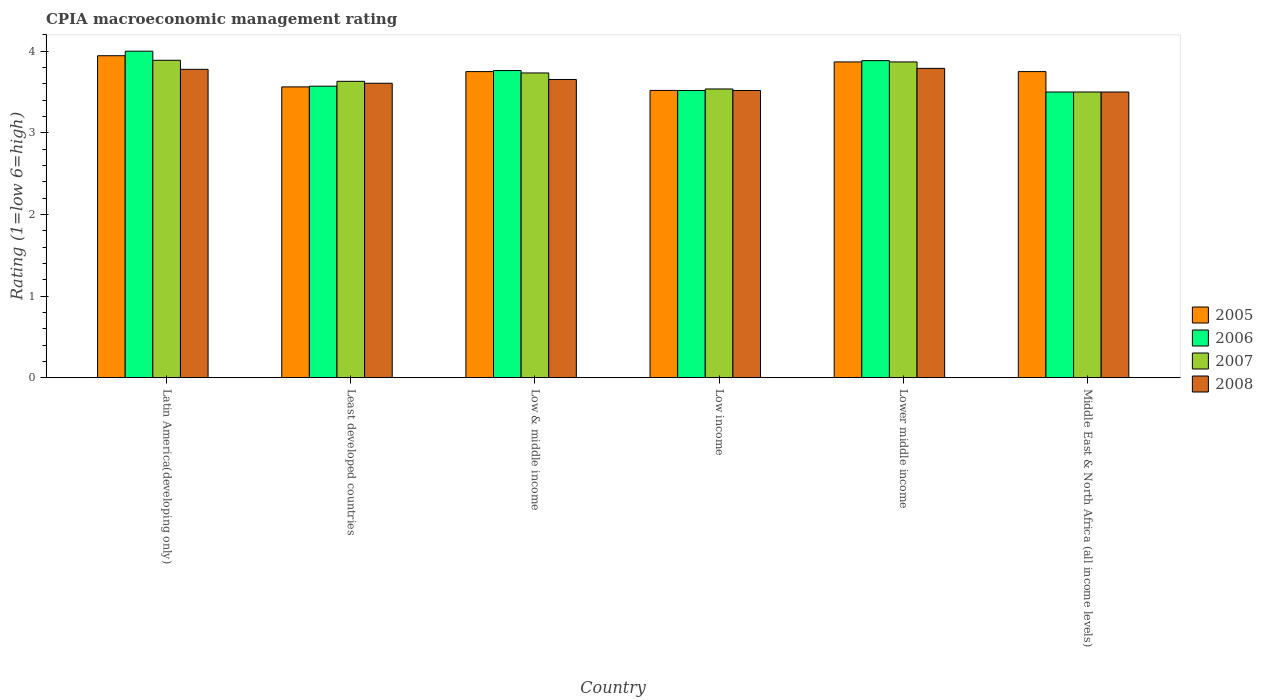How many different coloured bars are there?
Provide a succinct answer. 4. How many groups of bars are there?
Make the answer very short. 6. How many bars are there on the 6th tick from the left?
Provide a short and direct response. 4. What is the label of the 4th group of bars from the left?
Your answer should be compact. Low income. In how many cases, is the number of bars for a given country not equal to the number of legend labels?
Your response must be concise. 0. What is the CPIA rating in 2005 in Latin America(developing only)?
Keep it short and to the point. 3.94. Across all countries, what is the maximum CPIA rating in 2008?
Keep it short and to the point. 3.79. Across all countries, what is the minimum CPIA rating in 2008?
Make the answer very short. 3.5. In which country was the CPIA rating in 2005 maximum?
Your response must be concise. Latin America(developing only). In which country was the CPIA rating in 2007 minimum?
Make the answer very short. Middle East & North Africa (all income levels). What is the total CPIA rating in 2005 in the graph?
Offer a very short reply. 22.39. What is the difference between the CPIA rating in 2005 in Latin America(developing only) and that in Low income?
Make the answer very short. 0.43. What is the difference between the CPIA rating in 2007 in Low income and the CPIA rating in 2005 in Middle East & North Africa (all income levels)?
Make the answer very short. -0.21. What is the average CPIA rating in 2006 per country?
Provide a succinct answer. 3.71. What is the difference between the CPIA rating of/in 2007 and CPIA rating of/in 2006 in Low & middle income?
Your answer should be compact. -0.03. What is the ratio of the CPIA rating in 2007 in Low & middle income to that in Lower middle income?
Offer a terse response. 0.97. What is the difference between the highest and the second highest CPIA rating in 2005?
Your answer should be compact. 0.12. What is the difference between the highest and the lowest CPIA rating in 2008?
Provide a succinct answer. 0.29. In how many countries, is the CPIA rating in 2008 greater than the average CPIA rating in 2008 taken over all countries?
Ensure brevity in your answer.  3. What is the difference between two consecutive major ticks on the Y-axis?
Give a very brief answer. 1. Are the values on the major ticks of Y-axis written in scientific E-notation?
Offer a very short reply. No. What is the title of the graph?
Your response must be concise. CPIA macroeconomic management rating. Does "1995" appear as one of the legend labels in the graph?
Give a very brief answer. No. What is the label or title of the Y-axis?
Your answer should be very brief. Rating (1=low 6=high). What is the Rating (1=low 6=high) in 2005 in Latin America(developing only)?
Your answer should be compact. 3.94. What is the Rating (1=low 6=high) of 2007 in Latin America(developing only)?
Keep it short and to the point. 3.89. What is the Rating (1=low 6=high) in 2008 in Latin America(developing only)?
Offer a very short reply. 3.78. What is the Rating (1=low 6=high) of 2005 in Least developed countries?
Offer a very short reply. 3.56. What is the Rating (1=low 6=high) in 2006 in Least developed countries?
Provide a short and direct response. 3.57. What is the Rating (1=low 6=high) in 2007 in Least developed countries?
Provide a succinct answer. 3.63. What is the Rating (1=low 6=high) of 2008 in Least developed countries?
Provide a short and direct response. 3.61. What is the Rating (1=low 6=high) of 2005 in Low & middle income?
Your answer should be compact. 3.75. What is the Rating (1=low 6=high) of 2006 in Low & middle income?
Give a very brief answer. 3.76. What is the Rating (1=low 6=high) in 2007 in Low & middle income?
Give a very brief answer. 3.73. What is the Rating (1=low 6=high) of 2008 in Low & middle income?
Provide a succinct answer. 3.65. What is the Rating (1=low 6=high) of 2005 in Low income?
Give a very brief answer. 3.52. What is the Rating (1=low 6=high) in 2006 in Low income?
Your response must be concise. 3.52. What is the Rating (1=low 6=high) in 2007 in Low income?
Your response must be concise. 3.54. What is the Rating (1=low 6=high) of 2008 in Low income?
Ensure brevity in your answer.  3.52. What is the Rating (1=low 6=high) in 2005 in Lower middle income?
Offer a very short reply. 3.87. What is the Rating (1=low 6=high) of 2006 in Lower middle income?
Ensure brevity in your answer.  3.88. What is the Rating (1=low 6=high) of 2007 in Lower middle income?
Ensure brevity in your answer.  3.87. What is the Rating (1=low 6=high) in 2008 in Lower middle income?
Make the answer very short. 3.79. What is the Rating (1=low 6=high) of 2005 in Middle East & North Africa (all income levels)?
Make the answer very short. 3.75. What is the Rating (1=low 6=high) in 2007 in Middle East & North Africa (all income levels)?
Provide a succinct answer. 3.5. Across all countries, what is the maximum Rating (1=low 6=high) in 2005?
Your answer should be very brief. 3.94. Across all countries, what is the maximum Rating (1=low 6=high) of 2006?
Your answer should be very brief. 4. Across all countries, what is the maximum Rating (1=low 6=high) of 2007?
Your response must be concise. 3.89. Across all countries, what is the maximum Rating (1=low 6=high) of 2008?
Your answer should be compact. 3.79. Across all countries, what is the minimum Rating (1=low 6=high) of 2005?
Give a very brief answer. 3.52. Across all countries, what is the minimum Rating (1=low 6=high) of 2006?
Keep it short and to the point. 3.5. What is the total Rating (1=low 6=high) in 2005 in the graph?
Offer a very short reply. 22.39. What is the total Rating (1=low 6=high) in 2006 in the graph?
Your answer should be very brief. 22.24. What is the total Rating (1=low 6=high) in 2007 in the graph?
Provide a succinct answer. 22.16. What is the total Rating (1=low 6=high) in 2008 in the graph?
Offer a terse response. 21.85. What is the difference between the Rating (1=low 6=high) of 2005 in Latin America(developing only) and that in Least developed countries?
Give a very brief answer. 0.38. What is the difference between the Rating (1=low 6=high) of 2006 in Latin America(developing only) and that in Least developed countries?
Give a very brief answer. 0.43. What is the difference between the Rating (1=low 6=high) of 2007 in Latin America(developing only) and that in Least developed countries?
Your answer should be very brief. 0.26. What is the difference between the Rating (1=low 6=high) of 2008 in Latin America(developing only) and that in Least developed countries?
Make the answer very short. 0.17. What is the difference between the Rating (1=low 6=high) of 2005 in Latin America(developing only) and that in Low & middle income?
Offer a terse response. 0.19. What is the difference between the Rating (1=low 6=high) in 2006 in Latin America(developing only) and that in Low & middle income?
Provide a succinct answer. 0.24. What is the difference between the Rating (1=low 6=high) in 2007 in Latin America(developing only) and that in Low & middle income?
Make the answer very short. 0.16. What is the difference between the Rating (1=low 6=high) of 2008 in Latin America(developing only) and that in Low & middle income?
Offer a terse response. 0.12. What is the difference between the Rating (1=low 6=high) in 2005 in Latin America(developing only) and that in Low income?
Keep it short and to the point. 0.43. What is the difference between the Rating (1=low 6=high) in 2006 in Latin America(developing only) and that in Low income?
Your answer should be very brief. 0.48. What is the difference between the Rating (1=low 6=high) of 2007 in Latin America(developing only) and that in Low income?
Keep it short and to the point. 0.35. What is the difference between the Rating (1=low 6=high) in 2008 in Latin America(developing only) and that in Low income?
Your answer should be very brief. 0.26. What is the difference between the Rating (1=low 6=high) in 2005 in Latin America(developing only) and that in Lower middle income?
Your answer should be very brief. 0.08. What is the difference between the Rating (1=low 6=high) in 2006 in Latin America(developing only) and that in Lower middle income?
Offer a very short reply. 0.12. What is the difference between the Rating (1=low 6=high) of 2007 in Latin America(developing only) and that in Lower middle income?
Give a very brief answer. 0.02. What is the difference between the Rating (1=low 6=high) in 2008 in Latin America(developing only) and that in Lower middle income?
Your answer should be very brief. -0.01. What is the difference between the Rating (1=low 6=high) in 2005 in Latin America(developing only) and that in Middle East & North Africa (all income levels)?
Your response must be concise. 0.19. What is the difference between the Rating (1=low 6=high) in 2007 in Latin America(developing only) and that in Middle East & North Africa (all income levels)?
Give a very brief answer. 0.39. What is the difference between the Rating (1=low 6=high) of 2008 in Latin America(developing only) and that in Middle East & North Africa (all income levels)?
Your answer should be compact. 0.28. What is the difference between the Rating (1=low 6=high) in 2005 in Least developed countries and that in Low & middle income?
Keep it short and to the point. -0.19. What is the difference between the Rating (1=low 6=high) of 2006 in Least developed countries and that in Low & middle income?
Your answer should be compact. -0.19. What is the difference between the Rating (1=low 6=high) in 2007 in Least developed countries and that in Low & middle income?
Ensure brevity in your answer.  -0.1. What is the difference between the Rating (1=low 6=high) in 2008 in Least developed countries and that in Low & middle income?
Offer a terse response. -0.05. What is the difference between the Rating (1=low 6=high) of 2005 in Least developed countries and that in Low income?
Offer a very short reply. 0.04. What is the difference between the Rating (1=low 6=high) of 2006 in Least developed countries and that in Low income?
Keep it short and to the point. 0.05. What is the difference between the Rating (1=low 6=high) in 2007 in Least developed countries and that in Low income?
Provide a short and direct response. 0.09. What is the difference between the Rating (1=low 6=high) of 2008 in Least developed countries and that in Low income?
Provide a short and direct response. 0.09. What is the difference between the Rating (1=low 6=high) in 2005 in Least developed countries and that in Lower middle income?
Offer a terse response. -0.31. What is the difference between the Rating (1=low 6=high) in 2006 in Least developed countries and that in Lower middle income?
Ensure brevity in your answer.  -0.31. What is the difference between the Rating (1=low 6=high) of 2007 in Least developed countries and that in Lower middle income?
Make the answer very short. -0.24. What is the difference between the Rating (1=low 6=high) in 2008 in Least developed countries and that in Lower middle income?
Your response must be concise. -0.18. What is the difference between the Rating (1=low 6=high) in 2005 in Least developed countries and that in Middle East & North Africa (all income levels)?
Keep it short and to the point. -0.19. What is the difference between the Rating (1=low 6=high) in 2006 in Least developed countries and that in Middle East & North Africa (all income levels)?
Offer a terse response. 0.07. What is the difference between the Rating (1=low 6=high) in 2007 in Least developed countries and that in Middle East & North Africa (all income levels)?
Your answer should be compact. 0.13. What is the difference between the Rating (1=low 6=high) of 2008 in Least developed countries and that in Middle East & North Africa (all income levels)?
Make the answer very short. 0.11. What is the difference between the Rating (1=low 6=high) of 2005 in Low & middle income and that in Low income?
Offer a terse response. 0.23. What is the difference between the Rating (1=low 6=high) of 2006 in Low & middle income and that in Low income?
Your answer should be compact. 0.24. What is the difference between the Rating (1=low 6=high) of 2007 in Low & middle income and that in Low income?
Your response must be concise. 0.2. What is the difference between the Rating (1=low 6=high) of 2008 in Low & middle income and that in Low income?
Provide a succinct answer. 0.13. What is the difference between the Rating (1=low 6=high) in 2005 in Low & middle income and that in Lower middle income?
Make the answer very short. -0.12. What is the difference between the Rating (1=low 6=high) in 2006 in Low & middle income and that in Lower middle income?
Make the answer very short. -0.12. What is the difference between the Rating (1=low 6=high) of 2007 in Low & middle income and that in Lower middle income?
Offer a very short reply. -0.14. What is the difference between the Rating (1=low 6=high) of 2008 in Low & middle income and that in Lower middle income?
Make the answer very short. -0.14. What is the difference between the Rating (1=low 6=high) of 2005 in Low & middle income and that in Middle East & North Africa (all income levels)?
Your answer should be compact. 0. What is the difference between the Rating (1=low 6=high) in 2006 in Low & middle income and that in Middle East & North Africa (all income levels)?
Offer a terse response. 0.26. What is the difference between the Rating (1=low 6=high) in 2007 in Low & middle income and that in Middle East & North Africa (all income levels)?
Make the answer very short. 0.23. What is the difference between the Rating (1=low 6=high) of 2008 in Low & middle income and that in Middle East & North Africa (all income levels)?
Your answer should be very brief. 0.15. What is the difference between the Rating (1=low 6=high) of 2005 in Low income and that in Lower middle income?
Your answer should be very brief. -0.35. What is the difference between the Rating (1=low 6=high) in 2006 in Low income and that in Lower middle income?
Offer a terse response. -0.37. What is the difference between the Rating (1=low 6=high) of 2007 in Low income and that in Lower middle income?
Give a very brief answer. -0.33. What is the difference between the Rating (1=low 6=high) of 2008 in Low income and that in Lower middle income?
Ensure brevity in your answer.  -0.27. What is the difference between the Rating (1=low 6=high) of 2005 in Low income and that in Middle East & North Africa (all income levels)?
Offer a terse response. -0.23. What is the difference between the Rating (1=low 6=high) in 2006 in Low income and that in Middle East & North Africa (all income levels)?
Offer a very short reply. 0.02. What is the difference between the Rating (1=low 6=high) in 2007 in Low income and that in Middle East & North Africa (all income levels)?
Offer a terse response. 0.04. What is the difference between the Rating (1=low 6=high) in 2008 in Low income and that in Middle East & North Africa (all income levels)?
Make the answer very short. 0.02. What is the difference between the Rating (1=low 6=high) in 2005 in Lower middle income and that in Middle East & North Africa (all income levels)?
Keep it short and to the point. 0.12. What is the difference between the Rating (1=low 6=high) in 2006 in Lower middle income and that in Middle East & North Africa (all income levels)?
Give a very brief answer. 0.38. What is the difference between the Rating (1=low 6=high) in 2007 in Lower middle income and that in Middle East & North Africa (all income levels)?
Your answer should be compact. 0.37. What is the difference between the Rating (1=low 6=high) in 2008 in Lower middle income and that in Middle East & North Africa (all income levels)?
Keep it short and to the point. 0.29. What is the difference between the Rating (1=low 6=high) in 2005 in Latin America(developing only) and the Rating (1=low 6=high) in 2006 in Least developed countries?
Keep it short and to the point. 0.37. What is the difference between the Rating (1=low 6=high) of 2005 in Latin America(developing only) and the Rating (1=low 6=high) of 2007 in Least developed countries?
Ensure brevity in your answer.  0.31. What is the difference between the Rating (1=low 6=high) of 2005 in Latin America(developing only) and the Rating (1=low 6=high) of 2008 in Least developed countries?
Your answer should be compact. 0.34. What is the difference between the Rating (1=low 6=high) of 2006 in Latin America(developing only) and the Rating (1=low 6=high) of 2007 in Least developed countries?
Give a very brief answer. 0.37. What is the difference between the Rating (1=low 6=high) in 2006 in Latin America(developing only) and the Rating (1=low 6=high) in 2008 in Least developed countries?
Ensure brevity in your answer.  0.39. What is the difference between the Rating (1=low 6=high) in 2007 in Latin America(developing only) and the Rating (1=low 6=high) in 2008 in Least developed countries?
Provide a succinct answer. 0.28. What is the difference between the Rating (1=low 6=high) of 2005 in Latin America(developing only) and the Rating (1=low 6=high) of 2006 in Low & middle income?
Your answer should be compact. 0.18. What is the difference between the Rating (1=low 6=high) in 2005 in Latin America(developing only) and the Rating (1=low 6=high) in 2007 in Low & middle income?
Your answer should be compact. 0.21. What is the difference between the Rating (1=low 6=high) in 2005 in Latin America(developing only) and the Rating (1=low 6=high) in 2008 in Low & middle income?
Provide a succinct answer. 0.29. What is the difference between the Rating (1=low 6=high) of 2006 in Latin America(developing only) and the Rating (1=low 6=high) of 2007 in Low & middle income?
Offer a terse response. 0.27. What is the difference between the Rating (1=low 6=high) in 2006 in Latin America(developing only) and the Rating (1=low 6=high) in 2008 in Low & middle income?
Offer a terse response. 0.35. What is the difference between the Rating (1=low 6=high) in 2007 in Latin America(developing only) and the Rating (1=low 6=high) in 2008 in Low & middle income?
Ensure brevity in your answer.  0.24. What is the difference between the Rating (1=low 6=high) in 2005 in Latin America(developing only) and the Rating (1=low 6=high) in 2006 in Low income?
Your answer should be very brief. 0.43. What is the difference between the Rating (1=low 6=high) of 2005 in Latin America(developing only) and the Rating (1=low 6=high) of 2007 in Low income?
Your answer should be very brief. 0.41. What is the difference between the Rating (1=low 6=high) of 2005 in Latin America(developing only) and the Rating (1=low 6=high) of 2008 in Low income?
Keep it short and to the point. 0.43. What is the difference between the Rating (1=low 6=high) in 2006 in Latin America(developing only) and the Rating (1=low 6=high) in 2007 in Low income?
Ensure brevity in your answer.  0.46. What is the difference between the Rating (1=low 6=high) in 2006 in Latin America(developing only) and the Rating (1=low 6=high) in 2008 in Low income?
Your answer should be very brief. 0.48. What is the difference between the Rating (1=low 6=high) of 2007 in Latin America(developing only) and the Rating (1=low 6=high) of 2008 in Low income?
Your answer should be compact. 0.37. What is the difference between the Rating (1=low 6=high) of 2005 in Latin America(developing only) and the Rating (1=low 6=high) of 2006 in Lower middle income?
Ensure brevity in your answer.  0.06. What is the difference between the Rating (1=low 6=high) of 2005 in Latin America(developing only) and the Rating (1=low 6=high) of 2007 in Lower middle income?
Ensure brevity in your answer.  0.08. What is the difference between the Rating (1=low 6=high) of 2005 in Latin America(developing only) and the Rating (1=low 6=high) of 2008 in Lower middle income?
Ensure brevity in your answer.  0.15. What is the difference between the Rating (1=low 6=high) in 2006 in Latin America(developing only) and the Rating (1=low 6=high) in 2007 in Lower middle income?
Your answer should be compact. 0.13. What is the difference between the Rating (1=low 6=high) of 2006 in Latin America(developing only) and the Rating (1=low 6=high) of 2008 in Lower middle income?
Provide a succinct answer. 0.21. What is the difference between the Rating (1=low 6=high) in 2007 in Latin America(developing only) and the Rating (1=low 6=high) in 2008 in Lower middle income?
Provide a succinct answer. 0.1. What is the difference between the Rating (1=low 6=high) of 2005 in Latin America(developing only) and the Rating (1=low 6=high) of 2006 in Middle East & North Africa (all income levels)?
Provide a succinct answer. 0.44. What is the difference between the Rating (1=low 6=high) of 2005 in Latin America(developing only) and the Rating (1=low 6=high) of 2007 in Middle East & North Africa (all income levels)?
Your response must be concise. 0.44. What is the difference between the Rating (1=low 6=high) of 2005 in Latin America(developing only) and the Rating (1=low 6=high) of 2008 in Middle East & North Africa (all income levels)?
Ensure brevity in your answer.  0.44. What is the difference between the Rating (1=low 6=high) in 2007 in Latin America(developing only) and the Rating (1=low 6=high) in 2008 in Middle East & North Africa (all income levels)?
Your response must be concise. 0.39. What is the difference between the Rating (1=low 6=high) in 2005 in Least developed countries and the Rating (1=low 6=high) in 2006 in Low & middle income?
Offer a very short reply. -0.2. What is the difference between the Rating (1=low 6=high) of 2005 in Least developed countries and the Rating (1=low 6=high) of 2007 in Low & middle income?
Provide a short and direct response. -0.17. What is the difference between the Rating (1=low 6=high) in 2005 in Least developed countries and the Rating (1=low 6=high) in 2008 in Low & middle income?
Your answer should be very brief. -0.09. What is the difference between the Rating (1=low 6=high) in 2006 in Least developed countries and the Rating (1=low 6=high) in 2007 in Low & middle income?
Ensure brevity in your answer.  -0.16. What is the difference between the Rating (1=low 6=high) in 2006 in Least developed countries and the Rating (1=low 6=high) in 2008 in Low & middle income?
Keep it short and to the point. -0.08. What is the difference between the Rating (1=low 6=high) of 2007 in Least developed countries and the Rating (1=low 6=high) of 2008 in Low & middle income?
Offer a very short reply. -0.02. What is the difference between the Rating (1=low 6=high) in 2005 in Least developed countries and the Rating (1=low 6=high) in 2006 in Low income?
Make the answer very short. 0.04. What is the difference between the Rating (1=low 6=high) in 2005 in Least developed countries and the Rating (1=low 6=high) in 2007 in Low income?
Give a very brief answer. 0.03. What is the difference between the Rating (1=low 6=high) in 2005 in Least developed countries and the Rating (1=low 6=high) in 2008 in Low income?
Provide a succinct answer. 0.04. What is the difference between the Rating (1=low 6=high) in 2006 in Least developed countries and the Rating (1=low 6=high) in 2007 in Low income?
Keep it short and to the point. 0.03. What is the difference between the Rating (1=low 6=high) of 2006 in Least developed countries and the Rating (1=low 6=high) of 2008 in Low income?
Keep it short and to the point. 0.05. What is the difference between the Rating (1=low 6=high) in 2007 in Least developed countries and the Rating (1=low 6=high) in 2008 in Low income?
Keep it short and to the point. 0.11. What is the difference between the Rating (1=low 6=high) of 2005 in Least developed countries and the Rating (1=low 6=high) of 2006 in Lower middle income?
Ensure brevity in your answer.  -0.32. What is the difference between the Rating (1=low 6=high) in 2005 in Least developed countries and the Rating (1=low 6=high) in 2007 in Lower middle income?
Offer a very short reply. -0.31. What is the difference between the Rating (1=low 6=high) in 2005 in Least developed countries and the Rating (1=low 6=high) in 2008 in Lower middle income?
Offer a very short reply. -0.23. What is the difference between the Rating (1=low 6=high) of 2006 in Least developed countries and the Rating (1=low 6=high) of 2007 in Lower middle income?
Provide a succinct answer. -0.3. What is the difference between the Rating (1=low 6=high) of 2006 in Least developed countries and the Rating (1=low 6=high) of 2008 in Lower middle income?
Keep it short and to the point. -0.22. What is the difference between the Rating (1=low 6=high) in 2007 in Least developed countries and the Rating (1=low 6=high) in 2008 in Lower middle income?
Your answer should be compact. -0.16. What is the difference between the Rating (1=low 6=high) of 2005 in Least developed countries and the Rating (1=low 6=high) of 2006 in Middle East & North Africa (all income levels)?
Give a very brief answer. 0.06. What is the difference between the Rating (1=low 6=high) of 2005 in Least developed countries and the Rating (1=low 6=high) of 2007 in Middle East & North Africa (all income levels)?
Your response must be concise. 0.06. What is the difference between the Rating (1=low 6=high) of 2005 in Least developed countries and the Rating (1=low 6=high) of 2008 in Middle East & North Africa (all income levels)?
Your answer should be very brief. 0.06. What is the difference between the Rating (1=low 6=high) of 2006 in Least developed countries and the Rating (1=low 6=high) of 2007 in Middle East & North Africa (all income levels)?
Provide a short and direct response. 0.07. What is the difference between the Rating (1=low 6=high) of 2006 in Least developed countries and the Rating (1=low 6=high) of 2008 in Middle East & North Africa (all income levels)?
Keep it short and to the point. 0.07. What is the difference between the Rating (1=low 6=high) in 2007 in Least developed countries and the Rating (1=low 6=high) in 2008 in Middle East & North Africa (all income levels)?
Keep it short and to the point. 0.13. What is the difference between the Rating (1=low 6=high) of 2005 in Low & middle income and the Rating (1=low 6=high) of 2006 in Low income?
Provide a succinct answer. 0.23. What is the difference between the Rating (1=low 6=high) in 2005 in Low & middle income and the Rating (1=low 6=high) in 2007 in Low income?
Provide a short and direct response. 0.21. What is the difference between the Rating (1=low 6=high) of 2005 in Low & middle income and the Rating (1=low 6=high) of 2008 in Low income?
Offer a very short reply. 0.23. What is the difference between the Rating (1=low 6=high) in 2006 in Low & middle income and the Rating (1=low 6=high) in 2007 in Low income?
Your answer should be compact. 0.23. What is the difference between the Rating (1=low 6=high) in 2006 in Low & middle income and the Rating (1=low 6=high) in 2008 in Low income?
Your answer should be compact. 0.24. What is the difference between the Rating (1=low 6=high) in 2007 in Low & middle income and the Rating (1=low 6=high) in 2008 in Low income?
Ensure brevity in your answer.  0.21. What is the difference between the Rating (1=low 6=high) of 2005 in Low & middle income and the Rating (1=low 6=high) of 2006 in Lower middle income?
Ensure brevity in your answer.  -0.13. What is the difference between the Rating (1=low 6=high) in 2005 in Low & middle income and the Rating (1=low 6=high) in 2007 in Lower middle income?
Your answer should be very brief. -0.12. What is the difference between the Rating (1=low 6=high) in 2005 in Low & middle income and the Rating (1=low 6=high) in 2008 in Lower middle income?
Keep it short and to the point. -0.04. What is the difference between the Rating (1=low 6=high) of 2006 in Low & middle income and the Rating (1=low 6=high) of 2007 in Lower middle income?
Keep it short and to the point. -0.11. What is the difference between the Rating (1=low 6=high) of 2006 in Low & middle income and the Rating (1=low 6=high) of 2008 in Lower middle income?
Keep it short and to the point. -0.03. What is the difference between the Rating (1=low 6=high) of 2007 in Low & middle income and the Rating (1=low 6=high) of 2008 in Lower middle income?
Offer a very short reply. -0.06. What is the difference between the Rating (1=low 6=high) of 2005 in Low & middle income and the Rating (1=low 6=high) of 2006 in Middle East & North Africa (all income levels)?
Keep it short and to the point. 0.25. What is the difference between the Rating (1=low 6=high) in 2005 in Low & middle income and the Rating (1=low 6=high) in 2007 in Middle East & North Africa (all income levels)?
Provide a short and direct response. 0.25. What is the difference between the Rating (1=low 6=high) of 2006 in Low & middle income and the Rating (1=low 6=high) of 2007 in Middle East & North Africa (all income levels)?
Provide a short and direct response. 0.26. What is the difference between the Rating (1=low 6=high) of 2006 in Low & middle income and the Rating (1=low 6=high) of 2008 in Middle East & North Africa (all income levels)?
Give a very brief answer. 0.26. What is the difference between the Rating (1=low 6=high) of 2007 in Low & middle income and the Rating (1=low 6=high) of 2008 in Middle East & North Africa (all income levels)?
Offer a very short reply. 0.23. What is the difference between the Rating (1=low 6=high) of 2005 in Low income and the Rating (1=low 6=high) of 2006 in Lower middle income?
Ensure brevity in your answer.  -0.37. What is the difference between the Rating (1=low 6=high) of 2005 in Low income and the Rating (1=low 6=high) of 2007 in Lower middle income?
Make the answer very short. -0.35. What is the difference between the Rating (1=low 6=high) in 2005 in Low income and the Rating (1=low 6=high) in 2008 in Lower middle income?
Ensure brevity in your answer.  -0.27. What is the difference between the Rating (1=low 6=high) in 2006 in Low income and the Rating (1=low 6=high) in 2007 in Lower middle income?
Offer a very short reply. -0.35. What is the difference between the Rating (1=low 6=high) of 2006 in Low income and the Rating (1=low 6=high) of 2008 in Lower middle income?
Your answer should be very brief. -0.27. What is the difference between the Rating (1=low 6=high) in 2007 in Low income and the Rating (1=low 6=high) in 2008 in Lower middle income?
Your response must be concise. -0.25. What is the difference between the Rating (1=low 6=high) of 2005 in Low income and the Rating (1=low 6=high) of 2006 in Middle East & North Africa (all income levels)?
Offer a terse response. 0.02. What is the difference between the Rating (1=low 6=high) in 2005 in Low income and the Rating (1=low 6=high) in 2007 in Middle East & North Africa (all income levels)?
Provide a short and direct response. 0.02. What is the difference between the Rating (1=low 6=high) of 2005 in Low income and the Rating (1=low 6=high) of 2008 in Middle East & North Africa (all income levels)?
Ensure brevity in your answer.  0.02. What is the difference between the Rating (1=low 6=high) in 2006 in Low income and the Rating (1=low 6=high) in 2007 in Middle East & North Africa (all income levels)?
Provide a succinct answer. 0.02. What is the difference between the Rating (1=low 6=high) of 2006 in Low income and the Rating (1=low 6=high) of 2008 in Middle East & North Africa (all income levels)?
Offer a very short reply. 0.02. What is the difference between the Rating (1=low 6=high) in 2007 in Low income and the Rating (1=low 6=high) in 2008 in Middle East & North Africa (all income levels)?
Your response must be concise. 0.04. What is the difference between the Rating (1=low 6=high) of 2005 in Lower middle income and the Rating (1=low 6=high) of 2006 in Middle East & North Africa (all income levels)?
Ensure brevity in your answer.  0.37. What is the difference between the Rating (1=low 6=high) of 2005 in Lower middle income and the Rating (1=low 6=high) of 2007 in Middle East & North Africa (all income levels)?
Your answer should be very brief. 0.37. What is the difference between the Rating (1=low 6=high) in 2005 in Lower middle income and the Rating (1=low 6=high) in 2008 in Middle East & North Africa (all income levels)?
Your answer should be very brief. 0.37. What is the difference between the Rating (1=low 6=high) of 2006 in Lower middle income and the Rating (1=low 6=high) of 2007 in Middle East & North Africa (all income levels)?
Your answer should be very brief. 0.38. What is the difference between the Rating (1=low 6=high) in 2006 in Lower middle income and the Rating (1=low 6=high) in 2008 in Middle East & North Africa (all income levels)?
Ensure brevity in your answer.  0.38. What is the difference between the Rating (1=low 6=high) in 2007 in Lower middle income and the Rating (1=low 6=high) in 2008 in Middle East & North Africa (all income levels)?
Provide a short and direct response. 0.37. What is the average Rating (1=low 6=high) of 2005 per country?
Make the answer very short. 3.73. What is the average Rating (1=low 6=high) of 2006 per country?
Make the answer very short. 3.71. What is the average Rating (1=low 6=high) in 2007 per country?
Your response must be concise. 3.69. What is the average Rating (1=low 6=high) of 2008 per country?
Your response must be concise. 3.64. What is the difference between the Rating (1=low 6=high) in 2005 and Rating (1=low 6=high) in 2006 in Latin America(developing only)?
Ensure brevity in your answer.  -0.06. What is the difference between the Rating (1=low 6=high) of 2005 and Rating (1=low 6=high) of 2007 in Latin America(developing only)?
Provide a succinct answer. 0.06. What is the difference between the Rating (1=low 6=high) of 2005 and Rating (1=low 6=high) of 2008 in Latin America(developing only)?
Offer a terse response. 0.17. What is the difference between the Rating (1=low 6=high) in 2006 and Rating (1=low 6=high) in 2008 in Latin America(developing only)?
Offer a very short reply. 0.22. What is the difference between the Rating (1=low 6=high) of 2005 and Rating (1=low 6=high) of 2006 in Least developed countries?
Make the answer very short. -0.01. What is the difference between the Rating (1=low 6=high) in 2005 and Rating (1=low 6=high) in 2007 in Least developed countries?
Your answer should be compact. -0.07. What is the difference between the Rating (1=low 6=high) of 2005 and Rating (1=low 6=high) of 2008 in Least developed countries?
Provide a short and direct response. -0.04. What is the difference between the Rating (1=low 6=high) in 2006 and Rating (1=low 6=high) in 2007 in Least developed countries?
Give a very brief answer. -0.06. What is the difference between the Rating (1=low 6=high) in 2006 and Rating (1=low 6=high) in 2008 in Least developed countries?
Your answer should be compact. -0.04. What is the difference between the Rating (1=low 6=high) of 2007 and Rating (1=low 6=high) of 2008 in Least developed countries?
Your answer should be very brief. 0.02. What is the difference between the Rating (1=low 6=high) in 2005 and Rating (1=low 6=high) in 2006 in Low & middle income?
Your answer should be compact. -0.01. What is the difference between the Rating (1=low 6=high) of 2005 and Rating (1=low 6=high) of 2007 in Low & middle income?
Keep it short and to the point. 0.02. What is the difference between the Rating (1=low 6=high) of 2005 and Rating (1=low 6=high) of 2008 in Low & middle income?
Ensure brevity in your answer.  0.1. What is the difference between the Rating (1=low 6=high) of 2006 and Rating (1=low 6=high) of 2007 in Low & middle income?
Offer a very short reply. 0.03. What is the difference between the Rating (1=low 6=high) in 2006 and Rating (1=low 6=high) in 2008 in Low & middle income?
Give a very brief answer. 0.11. What is the difference between the Rating (1=low 6=high) in 2007 and Rating (1=low 6=high) in 2008 in Low & middle income?
Give a very brief answer. 0.08. What is the difference between the Rating (1=low 6=high) in 2005 and Rating (1=low 6=high) in 2006 in Low income?
Provide a succinct answer. 0. What is the difference between the Rating (1=low 6=high) in 2005 and Rating (1=low 6=high) in 2007 in Low income?
Offer a terse response. -0.02. What is the difference between the Rating (1=low 6=high) in 2005 and Rating (1=low 6=high) in 2008 in Low income?
Your response must be concise. 0. What is the difference between the Rating (1=low 6=high) of 2006 and Rating (1=low 6=high) of 2007 in Low income?
Give a very brief answer. -0.02. What is the difference between the Rating (1=low 6=high) in 2006 and Rating (1=low 6=high) in 2008 in Low income?
Provide a succinct answer. 0. What is the difference between the Rating (1=low 6=high) in 2007 and Rating (1=low 6=high) in 2008 in Low income?
Offer a very short reply. 0.02. What is the difference between the Rating (1=low 6=high) of 2005 and Rating (1=low 6=high) of 2006 in Lower middle income?
Your response must be concise. -0.02. What is the difference between the Rating (1=low 6=high) of 2005 and Rating (1=low 6=high) of 2008 in Lower middle income?
Give a very brief answer. 0.08. What is the difference between the Rating (1=low 6=high) in 2006 and Rating (1=low 6=high) in 2007 in Lower middle income?
Provide a succinct answer. 0.02. What is the difference between the Rating (1=low 6=high) in 2006 and Rating (1=low 6=high) in 2008 in Lower middle income?
Your answer should be very brief. 0.1. What is the difference between the Rating (1=low 6=high) in 2007 and Rating (1=low 6=high) in 2008 in Lower middle income?
Give a very brief answer. 0.08. What is the difference between the Rating (1=low 6=high) in 2006 and Rating (1=low 6=high) in 2007 in Middle East & North Africa (all income levels)?
Keep it short and to the point. 0. What is the difference between the Rating (1=low 6=high) of 2006 and Rating (1=low 6=high) of 2008 in Middle East & North Africa (all income levels)?
Give a very brief answer. 0. What is the ratio of the Rating (1=low 6=high) of 2005 in Latin America(developing only) to that in Least developed countries?
Give a very brief answer. 1.11. What is the ratio of the Rating (1=low 6=high) of 2006 in Latin America(developing only) to that in Least developed countries?
Ensure brevity in your answer.  1.12. What is the ratio of the Rating (1=low 6=high) of 2007 in Latin America(developing only) to that in Least developed countries?
Provide a short and direct response. 1.07. What is the ratio of the Rating (1=low 6=high) in 2008 in Latin America(developing only) to that in Least developed countries?
Give a very brief answer. 1.05. What is the ratio of the Rating (1=low 6=high) in 2005 in Latin America(developing only) to that in Low & middle income?
Your answer should be compact. 1.05. What is the ratio of the Rating (1=low 6=high) in 2006 in Latin America(developing only) to that in Low & middle income?
Provide a succinct answer. 1.06. What is the ratio of the Rating (1=low 6=high) in 2007 in Latin America(developing only) to that in Low & middle income?
Keep it short and to the point. 1.04. What is the ratio of the Rating (1=low 6=high) in 2008 in Latin America(developing only) to that in Low & middle income?
Give a very brief answer. 1.03. What is the ratio of the Rating (1=low 6=high) of 2005 in Latin America(developing only) to that in Low income?
Make the answer very short. 1.12. What is the ratio of the Rating (1=low 6=high) in 2006 in Latin America(developing only) to that in Low income?
Offer a terse response. 1.14. What is the ratio of the Rating (1=low 6=high) of 2007 in Latin America(developing only) to that in Low income?
Provide a succinct answer. 1.1. What is the ratio of the Rating (1=low 6=high) in 2008 in Latin America(developing only) to that in Low income?
Provide a short and direct response. 1.07. What is the ratio of the Rating (1=low 6=high) in 2005 in Latin America(developing only) to that in Lower middle income?
Provide a short and direct response. 1.02. What is the ratio of the Rating (1=low 6=high) of 2006 in Latin America(developing only) to that in Lower middle income?
Your response must be concise. 1.03. What is the ratio of the Rating (1=low 6=high) of 2008 in Latin America(developing only) to that in Lower middle income?
Offer a very short reply. 1. What is the ratio of the Rating (1=low 6=high) of 2005 in Latin America(developing only) to that in Middle East & North Africa (all income levels)?
Keep it short and to the point. 1.05. What is the ratio of the Rating (1=low 6=high) in 2006 in Latin America(developing only) to that in Middle East & North Africa (all income levels)?
Your response must be concise. 1.14. What is the ratio of the Rating (1=low 6=high) of 2008 in Latin America(developing only) to that in Middle East & North Africa (all income levels)?
Ensure brevity in your answer.  1.08. What is the ratio of the Rating (1=low 6=high) of 2005 in Least developed countries to that in Low & middle income?
Provide a short and direct response. 0.95. What is the ratio of the Rating (1=low 6=high) of 2006 in Least developed countries to that in Low & middle income?
Ensure brevity in your answer.  0.95. What is the ratio of the Rating (1=low 6=high) of 2007 in Least developed countries to that in Low & middle income?
Provide a short and direct response. 0.97. What is the ratio of the Rating (1=low 6=high) in 2008 in Least developed countries to that in Low & middle income?
Your answer should be very brief. 0.99. What is the ratio of the Rating (1=low 6=high) in 2005 in Least developed countries to that in Low income?
Provide a short and direct response. 1.01. What is the ratio of the Rating (1=low 6=high) in 2006 in Least developed countries to that in Low income?
Make the answer very short. 1.01. What is the ratio of the Rating (1=low 6=high) in 2007 in Least developed countries to that in Low income?
Offer a very short reply. 1.03. What is the ratio of the Rating (1=low 6=high) in 2008 in Least developed countries to that in Low income?
Offer a very short reply. 1.03. What is the ratio of the Rating (1=low 6=high) of 2005 in Least developed countries to that in Lower middle income?
Provide a succinct answer. 0.92. What is the ratio of the Rating (1=low 6=high) of 2006 in Least developed countries to that in Lower middle income?
Provide a short and direct response. 0.92. What is the ratio of the Rating (1=low 6=high) of 2007 in Least developed countries to that in Lower middle income?
Your answer should be compact. 0.94. What is the ratio of the Rating (1=low 6=high) of 2008 in Least developed countries to that in Lower middle income?
Offer a very short reply. 0.95. What is the ratio of the Rating (1=low 6=high) of 2006 in Least developed countries to that in Middle East & North Africa (all income levels)?
Ensure brevity in your answer.  1.02. What is the ratio of the Rating (1=low 6=high) in 2007 in Least developed countries to that in Middle East & North Africa (all income levels)?
Your answer should be compact. 1.04. What is the ratio of the Rating (1=low 6=high) in 2008 in Least developed countries to that in Middle East & North Africa (all income levels)?
Keep it short and to the point. 1.03. What is the ratio of the Rating (1=low 6=high) in 2005 in Low & middle income to that in Low income?
Ensure brevity in your answer.  1.07. What is the ratio of the Rating (1=low 6=high) of 2006 in Low & middle income to that in Low income?
Give a very brief answer. 1.07. What is the ratio of the Rating (1=low 6=high) of 2007 in Low & middle income to that in Low income?
Provide a succinct answer. 1.06. What is the ratio of the Rating (1=low 6=high) in 2008 in Low & middle income to that in Low income?
Give a very brief answer. 1.04. What is the ratio of the Rating (1=low 6=high) of 2005 in Low & middle income to that in Lower middle income?
Ensure brevity in your answer.  0.97. What is the ratio of the Rating (1=low 6=high) in 2006 in Low & middle income to that in Lower middle income?
Ensure brevity in your answer.  0.97. What is the ratio of the Rating (1=low 6=high) in 2007 in Low & middle income to that in Lower middle income?
Offer a terse response. 0.97. What is the ratio of the Rating (1=low 6=high) of 2008 in Low & middle income to that in Lower middle income?
Your response must be concise. 0.96. What is the ratio of the Rating (1=low 6=high) of 2006 in Low & middle income to that in Middle East & North Africa (all income levels)?
Provide a short and direct response. 1.08. What is the ratio of the Rating (1=low 6=high) in 2007 in Low & middle income to that in Middle East & North Africa (all income levels)?
Give a very brief answer. 1.07. What is the ratio of the Rating (1=low 6=high) in 2008 in Low & middle income to that in Middle East & North Africa (all income levels)?
Your answer should be compact. 1.04. What is the ratio of the Rating (1=low 6=high) in 2005 in Low income to that in Lower middle income?
Your response must be concise. 0.91. What is the ratio of the Rating (1=low 6=high) in 2006 in Low income to that in Lower middle income?
Give a very brief answer. 0.91. What is the ratio of the Rating (1=low 6=high) of 2007 in Low income to that in Lower middle income?
Your answer should be compact. 0.91. What is the ratio of the Rating (1=low 6=high) of 2008 in Low income to that in Lower middle income?
Provide a succinct answer. 0.93. What is the ratio of the Rating (1=low 6=high) of 2005 in Low income to that in Middle East & North Africa (all income levels)?
Keep it short and to the point. 0.94. What is the ratio of the Rating (1=low 6=high) of 2007 in Low income to that in Middle East & North Africa (all income levels)?
Give a very brief answer. 1.01. What is the ratio of the Rating (1=low 6=high) of 2005 in Lower middle income to that in Middle East & North Africa (all income levels)?
Offer a terse response. 1.03. What is the ratio of the Rating (1=low 6=high) in 2006 in Lower middle income to that in Middle East & North Africa (all income levels)?
Your answer should be compact. 1.11. What is the ratio of the Rating (1=low 6=high) of 2007 in Lower middle income to that in Middle East & North Africa (all income levels)?
Your answer should be compact. 1.11. What is the ratio of the Rating (1=low 6=high) of 2008 in Lower middle income to that in Middle East & North Africa (all income levels)?
Offer a terse response. 1.08. What is the difference between the highest and the second highest Rating (1=low 6=high) in 2005?
Your response must be concise. 0.08. What is the difference between the highest and the second highest Rating (1=low 6=high) in 2006?
Provide a short and direct response. 0.12. What is the difference between the highest and the second highest Rating (1=low 6=high) of 2007?
Ensure brevity in your answer.  0.02. What is the difference between the highest and the second highest Rating (1=low 6=high) in 2008?
Your answer should be very brief. 0.01. What is the difference between the highest and the lowest Rating (1=low 6=high) in 2005?
Make the answer very short. 0.43. What is the difference between the highest and the lowest Rating (1=low 6=high) of 2006?
Keep it short and to the point. 0.5. What is the difference between the highest and the lowest Rating (1=low 6=high) in 2007?
Provide a succinct answer. 0.39. What is the difference between the highest and the lowest Rating (1=low 6=high) of 2008?
Offer a very short reply. 0.29. 